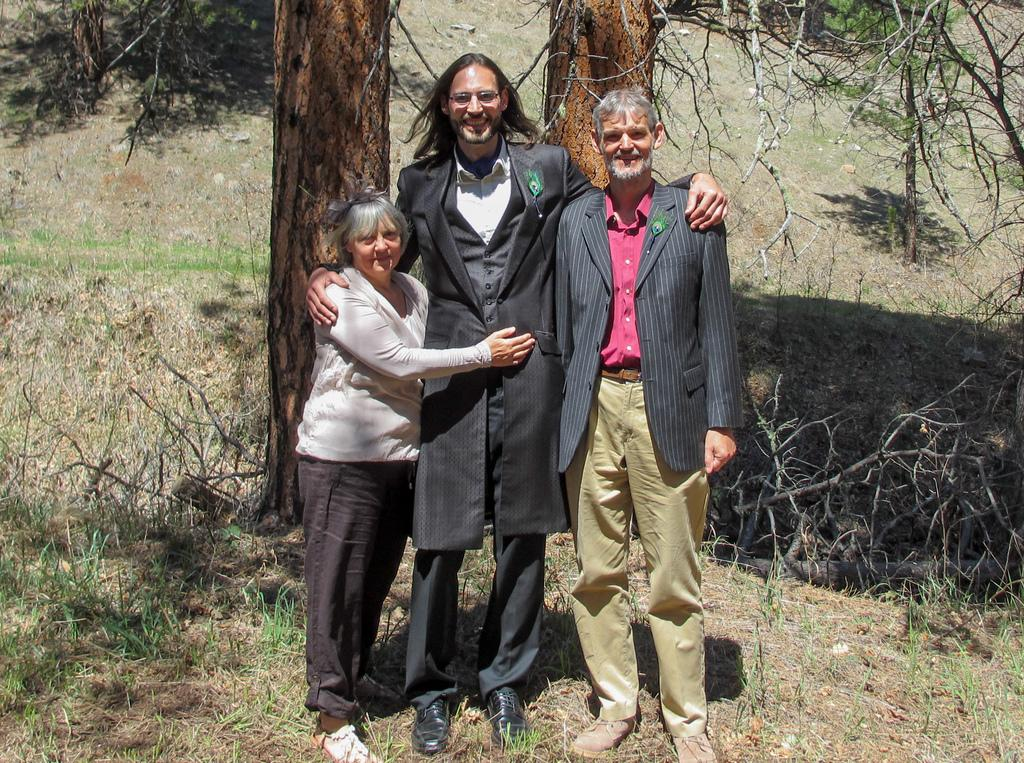How many people are in the image? There are two men and a woman in the image, making a total of three people. What are the individuals in the image doing? The individuals are standing and smiling in the image. What type of vegetation is visible at the bottom of the image? There is grass at the bottom of the image. What can be seen in the middle of the image? There are trees visible in the middle of the image. What type of test is being conducted on the trees in the image? There is no test being conducted on the trees in the image; they are simply visible in the middle of the image. 